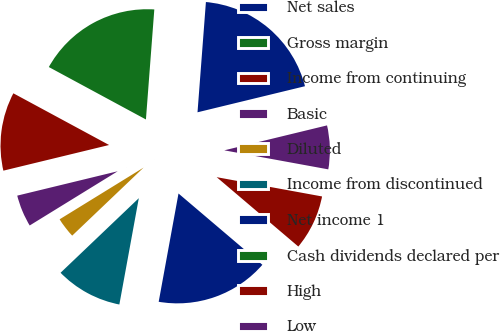Convert chart to OTSL. <chart><loc_0><loc_0><loc_500><loc_500><pie_chart><fcel>Net sales<fcel>Gross margin<fcel>Income from continuing<fcel>Basic<fcel>Diluted<fcel>Income from discontinued<fcel>Net income 1<fcel>Cash dividends declared per<fcel>High<fcel>Low<nl><fcel>20.0%<fcel>18.33%<fcel>11.67%<fcel>5.0%<fcel>3.33%<fcel>10.0%<fcel>16.67%<fcel>0.0%<fcel>8.33%<fcel>6.67%<nl></chart> 